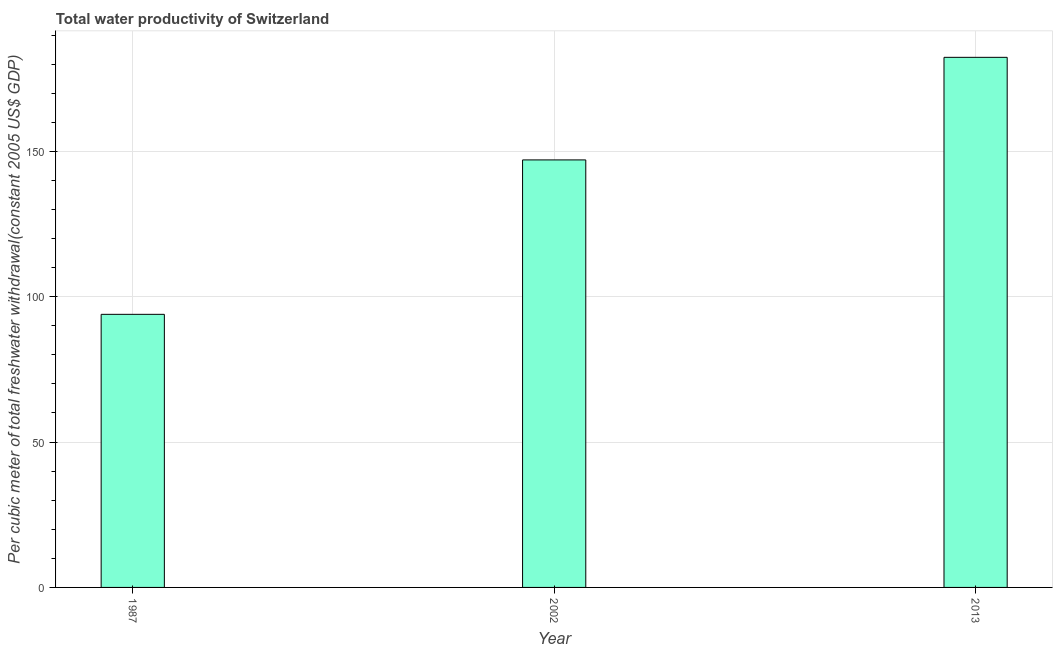Does the graph contain any zero values?
Ensure brevity in your answer.  No. What is the title of the graph?
Offer a terse response. Total water productivity of Switzerland. What is the label or title of the Y-axis?
Your response must be concise. Per cubic meter of total freshwater withdrawal(constant 2005 US$ GDP). What is the total water productivity in 2013?
Keep it short and to the point. 182.34. Across all years, what is the maximum total water productivity?
Keep it short and to the point. 182.34. Across all years, what is the minimum total water productivity?
Give a very brief answer. 93.93. In which year was the total water productivity minimum?
Ensure brevity in your answer.  1987. What is the sum of the total water productivity?
Offer a terse response. 423.32. What is the difference between the total water productivity in 2002 and 2013?
Provide a succinct answer. -35.29. What is the average total water productivity per year?
Offer a very short reply. 141.11. What is the median total water productivity?
Offer a very short reply. 147.05. What is the ratio of the total water productivity in 1987 to that in 2013?
Your answer should be very brief. 0.52. Is the difference between the total water productivity in 1987 and 2002 greater than the difference between any two years?
Your answer should be compact. No. What is the difference between the highest and the second highest total water productivity?
Provide a short and direct response. 35.29. What is the difference between the highest and the lowest total water productivity?
Make the answer very short. 88.4. Are all the bars in the graph horizontal?
Your response must be concise. No. How many years are there in the graph?
Your answer should be compact. 3. What is the difference between two consecutive major ticks on the Y-axis?
Provide a short and direct response. 50. Are the values on the major ticks of Y-axis written in scientific E-notation?
Your answer should be very brief. No. What is the Per cubic meter of total freshwater withdrawal(constant 2005 US$ GDP) of 1987?
Make the answer very short. 93.93. What is the Per cubic meter of total freshwater withdrawal(constant 2005 US$ GDP) in 2002?
Give a very brief answer. 147.05. What is the Per cubic meter of total freshwater withdrawal(constant 2005 US$ GDP) of 2013?
Offer a very short reply. 182.34. What is the difference between the Per cubic meter of total freshwater withdrawal(constant 2005 US$ GDP) in 1987 and 2002?
Ensure brevity in your answer.  -53.12. What is the difference between the Per cubic meter of total freshwater withdrawal(constant 2005 US$ GDP) in 1987 and 2013?
Provide a short and direct response. -88.4. What is the difference between the Per cubic meter of total freshwater withdrawal(constant 2005 US$ GDP) in 2002 and 2013?
Your answer should be compact. -35.29. What is the ratio of the Per cubic meter of total freshwater withdrawal(constant 2005 US$ GDP) in 1987 to that in 2002?
Give a very brief answer. 0.64. What is the ratio of the Per cubic meter of total freshwater withdrawal(constant 2005 US$ GDP) in 1987 to that in 2013?
Your answer should be very brief. 0.52. What is the ratio of the Per cubic meter of total freshwater withdrawal(constant 2005 US$ GDP) in 2002 to that in 2013?
Make the answer very short. 0.81. 